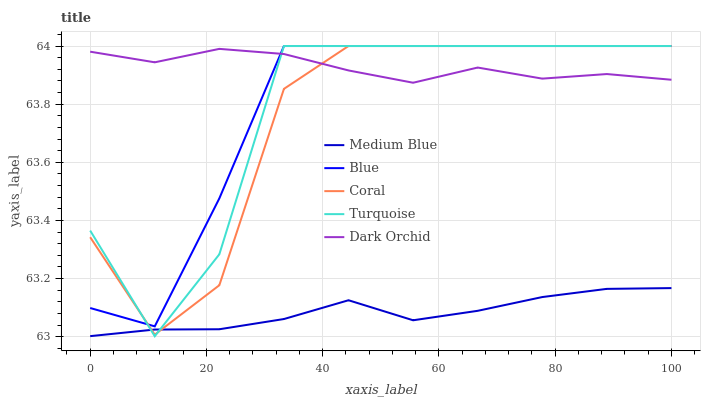Does Medium Blue have the minimum area under the curve?
Answer yes or no. Yes. Does Dark Orchid have the maximum area under the curve?
Answer yes or no. Yes. Does Coral have the minimum area under the curve?
Answer yes or no. No. Does Coral have the maximum area under the curve?
Answer yes or no. No. Is Medium Blue the smoothest?
Answer yes or no. Yes. Is Turquoise the roughest?
Answer yes or no. Yes. Is Coral the smoothest?
Answer yes or no. No. Is Coral the roughest?
Answer yes or no. No. Does Turquoise have the lowest value?
Answer yes or no. Yes. Does Coral have the lowest value?
Answer yes or no. No. Does Turquoise have the highest value?
Answer yes or no. Yes. Does Medium Blue have the highest value?
Answer yes or no. No. Is Medium Blue less than Blue?
Answer yes or no. Yes. Is Blue greater than Medium Blue?
Answer yes or no. Yes. Does Coral intersect Medium Blue?
Answer yes or no. Yes. Is Coral less than Medium Blue?
Answer yes or no. No. Is Coral greater than Medium Blue?
Answer yes or no. No. Does Medium Blue intersect Blue?
Answer yes or no. No. 